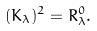Convert formula to latex. <formula><loc_0><loc_0><loc_500><loc_500>( K _ { \lambda } ) ^ { 2 } = R ^ { 0 } _ { \lambda } .</formula> 